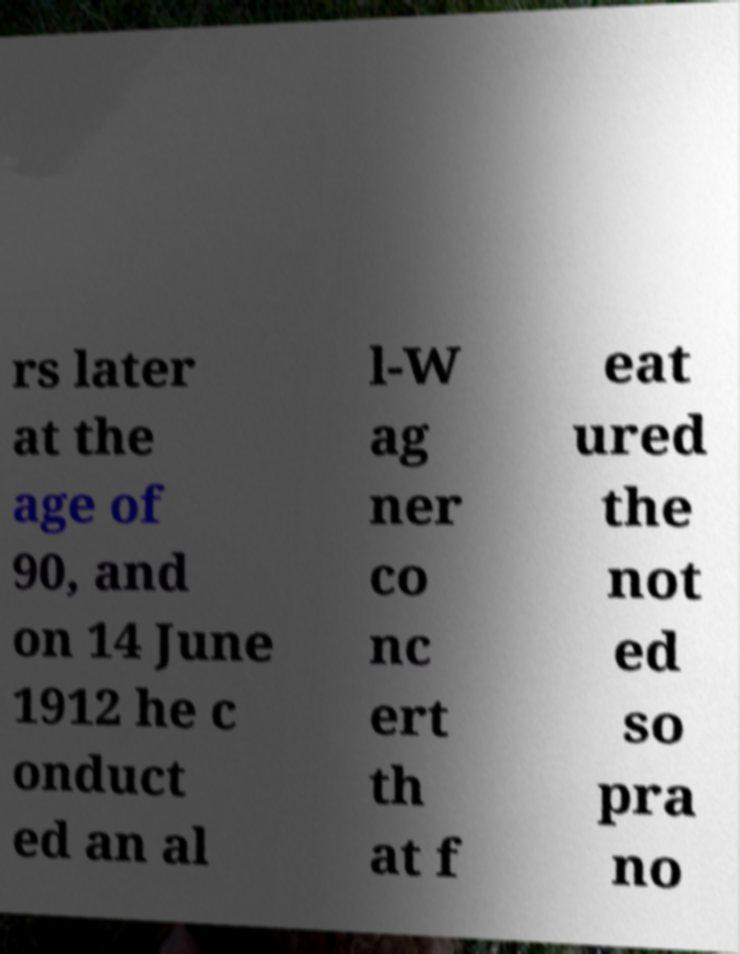There's text embedded in this image that I need extracted. Can you transcribe it verbatim? rs later at the age of 90, and on 14 June 1912 he c onduct ed an al l-W ag ner co nc ert th at f eat ured the not ed so pra no 